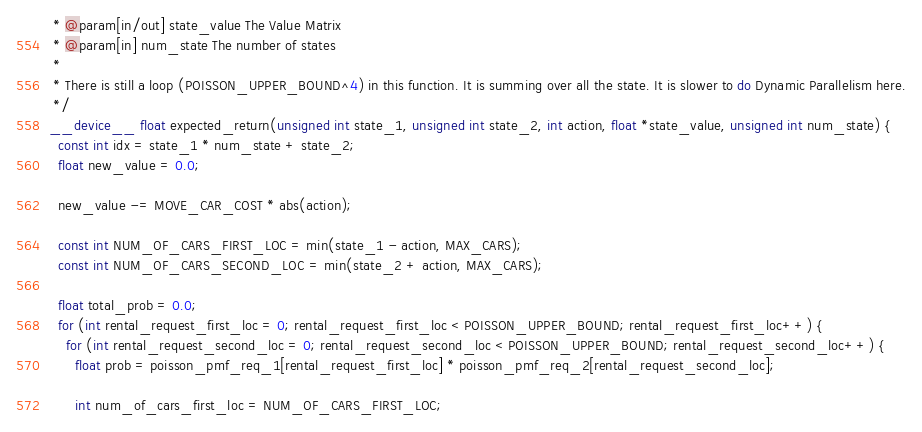Convert code to text. <code><loc_0><loc_0><loc_500><loc_500><_Cuda_> * @param[in/out] state_value The Value Matrix
 * @param[in] num_state The number of states
 * 
 * There is still a loop (POISSON_UPPER_BOUND^4) in this function. It is summing over all the state. It is slower to do Dynamic Parallelism here.
 */
__device__ float expected_return(unsigned int state_1, unsigned int state_2, int action, float *state_value, unsigned int num_state) {
  const int idx = state_1 * num_state + state_2;
  float new_value = 0.0;

  new_value -= MOVE_CAR_COST * abs(action);

  const int NUM_OF_CARS_FIRST_LOC = min(state_1 - action, MAX_CARS);
  const int NUM_OF_CARS_SECOND_LOC = min(state_2 + action, MAX_CARS);

  float total_prob = 0.0;
  for (int rental_request_first_loc = 0; rental_request_first_loc < POISSON_UPPER_BOUND; rental_request_first_loc++) {
    for (int rental_request_second_loc = 0; rental_request_second_loc < POISSON_UPPER_BOUND; rental_request_second_loc++) {
      float prob = poisson_pmf_req_1[rental_request_first_loc] * poisson_pmf_req_2[rental_request_second_loc];

      int num_of_cars_first_loc = NUM_OF_CARS_FIRST_LOC;</code> 